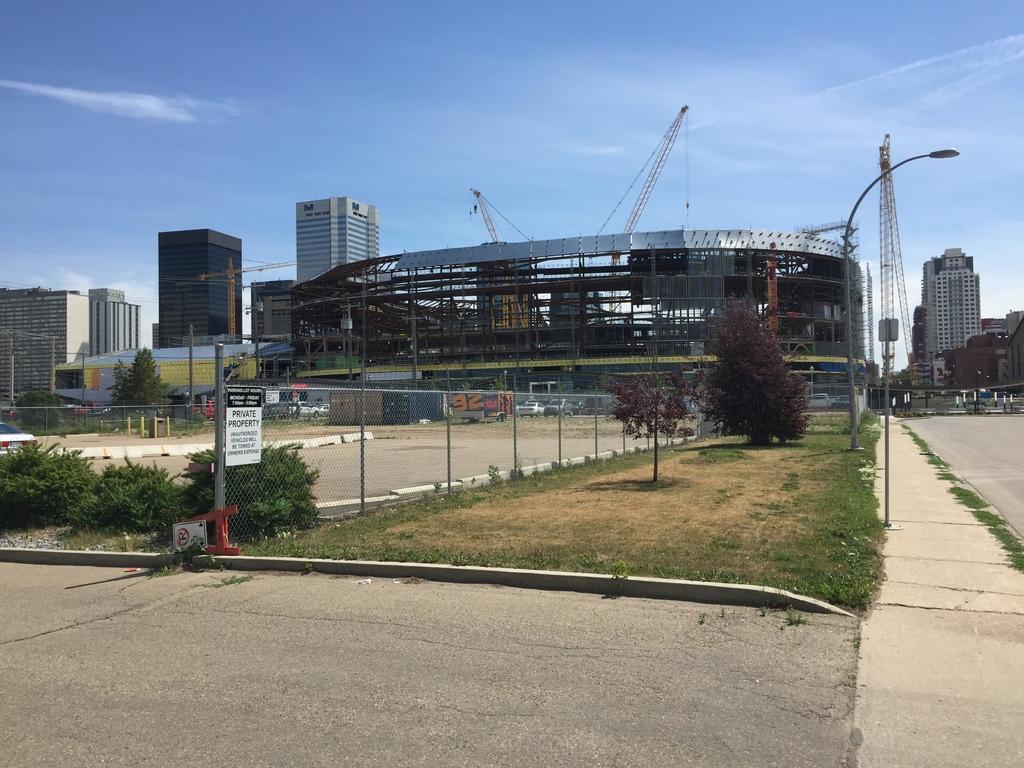How would you summarize this image in a sentence or two? In this picture I can see green grass. I can see walk way. I can see the metal grill fence. I can see the vehicles in the parking space. I can see construction building. I can see tower buildings on the right side and left side. I can see trees and plants. I can see tower cranes. I can see clouds in the sky. I can see the road. 